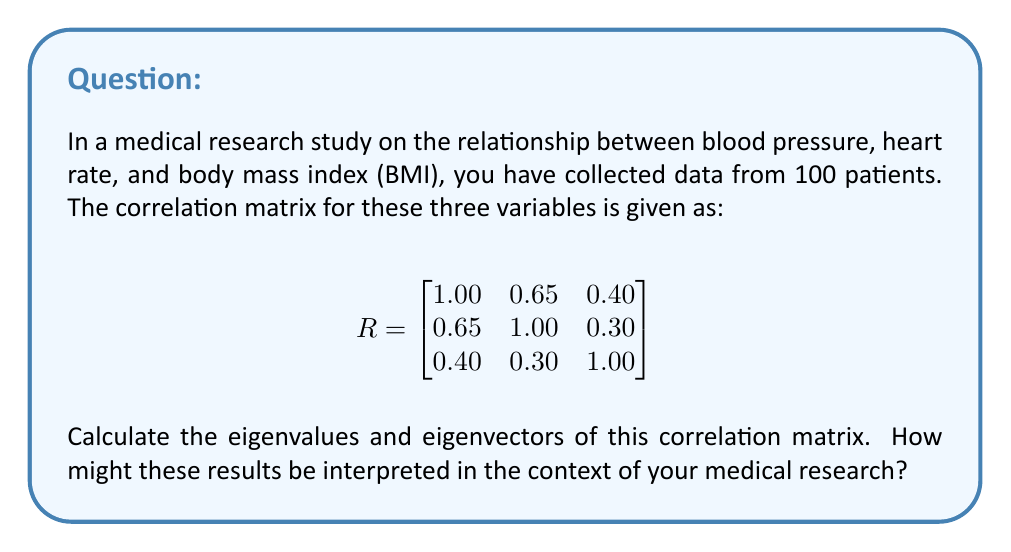Can you solve this math problem? To find the eigenvalues and eigenvectors of the correlation matrix R, we follow these steps:

1. Find the characteristic equation:
   $det(R - \lambda I) = 0$

   $$
   \begin{vmatrix}
   1-\lambda & 0.65 & 0.40 \\
   0.65 & 1-\lambda & 0.30 \\
   0.40 & 0.30 & 1-\lambda
   \end{vmatrix} = 0
   $$

2. Expand the determinant:
   $(1-\lambda)^3 - 0.65^2(1-\lambda) - 0.40^2(1-\lambda) - 0.30^2(1-\lambda) + 2(0.65)(0.40)(0.30) = 0$

3. Simplify:
   $-\lambda^3 + 3\lambda^2 - 2.1025\lambda + 0.4225 = 0$

4. Solve for $\lambda$ (eigenvalues):
   Using a numerical method or computer algebra system, we get:
   $\lambda_1 \approx 2.0546$
   $\lambda_2 \approx 0.6183$
   $\lambda_3 \approx 0.3271$

5. Find eigenvectors:
   For each eigenvalue $\lambda_i$, solve $(R - \lambda_i I)v_i = 0$

   For $\lambda_1 \approx 2.0546$:
   $$
   \begin{bmatrix}
   -1.0546 & 0.65 & 0.40 \\
   0.65 & -1.0546 & 0.30 \\
   0.40 & 0.30 & -1.0546
   \end{bmatrix}
   \begin{bmatrix}
   v_{11} \\ v_{21} \\ v_{31}
   \end{bmatrix} = 0
   $$

   Solving this system gives: $v_1 \approx [0.6498, 0.5985, 0.4682]^T$

   Similarly, for $\lambda_2$ and $\lambda_3$, we get:
   $v_2 \approx [-0.1656, -0.4245, 0.8901]^T$
   $v_3 \approx [0.7422, -0.6787, 0.0049]^T$

Interpretation:
The largest eigenvalue (2.0546) explains about 68.5% of the total variance, indicating a strong correlation between the variables. The corresponding eigenvector shows that all three variables contribute positively to this principal component, with blood pressure and heart rate having slightly larger contributions.

The second eigenvalue (0.6183) accounts for about 20.6% of the variance, with BMI having the largest contribution in the opposite direction to blood pressure and heart rate.

The third eigenvalue (0.3271) explains the remaining 10.9% of variance, mainly capturing the difference between blood pressure and heart rate.

This analysis suggests that there's a strong overall correlation between the three variables, but also some independent variation, particularly in BMI.
Answer: Eigenvalues: $\lambda_1 \approx 2.0546$, $\lambda_2 \approx 0.6183$, $\lambda_3 \approx 0.3271$
Eigenvectors: $v_1 \approx [0.6498, 0.5985, 0.4682]^T$, $v_2 \approx [-0.1656, -0.4245, 0.8901]^T$, $v_3 \approx [0.7422, -0.6787, 0.0049]^T$ 